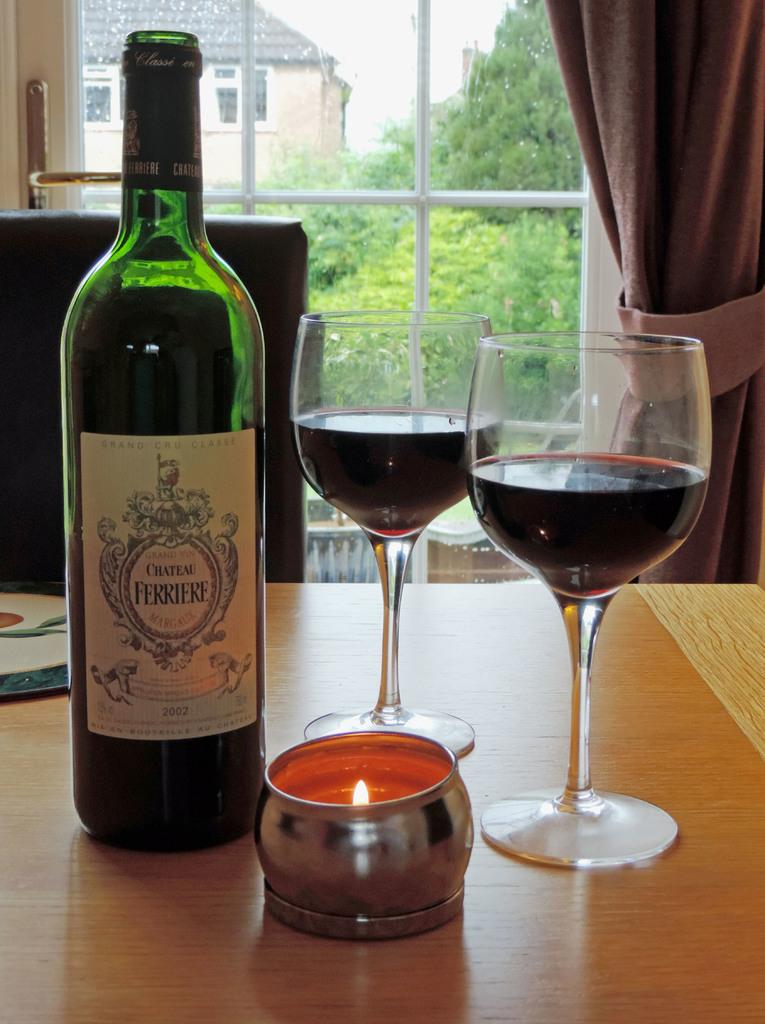<image>
Write a terse but informative summary of the picture. A bottle of Chateau Ferriere sits next to a candle. 